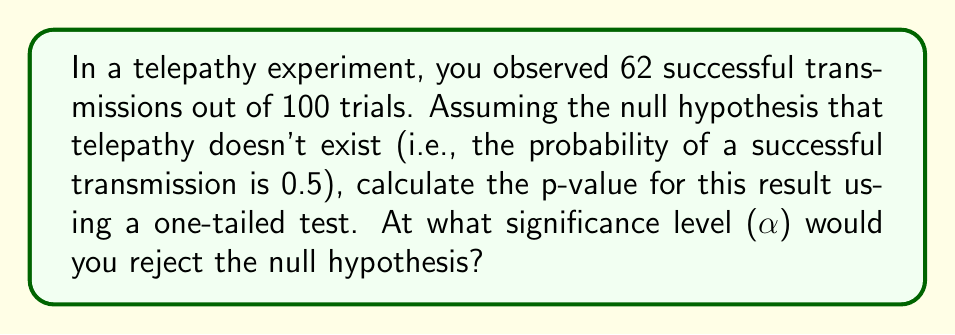Could you help me with this problem? To solve this problem, we'll use the binomial distribution and calculate the probability of observing 62 or more successes out of 100 trials if the true probability is 0.5.

Step 1: Define the parameters
n = 100 (number of trials)
k = 62 (number of successes)
p = 0.5 (probability of success under null hypothesis)

Step 2: Calculate the p-value using the cumulative binomial distribution
p-value = P(X ≥ 62), where X ~ Binomial(100, 0.5)

$$p\text{-value} = \sum_{i=62}^{100} \binom{100}{i} (0.5)^i (0.5)^{100-i}$$

Step 3: Use a statistical calculator or programming language to compute this sum
The result of this calculation is approximately 0.0099.

Step 4: Interpret the p-value
The p-value of 0.0099 means that if telepathy doesn't exist (null hypothesis is true), the probability of observing 62 or more successes out of 100 trials is about 0.99%.

Step 5: Determine the significance level for rejection
To reject the null hypothesis, we need a significance level (α) that is greater than the p-value. Common significance levels are 0.05, 0.01, and 0.001.

In this case:
- We would reject the null hypothesis at α = 0.05 (5% level)
- We would reject the null hypothesis at α = 0.01 (1% level)
- We would not reject the null hypothesis at α = 0.001 (0.1% level)

Therefore, the smallest standard significance level at which we would reject the null hypothesis is 0.01 or 1%.
Answer: p-value ≈ 0.0099; reject at α = 0.01 